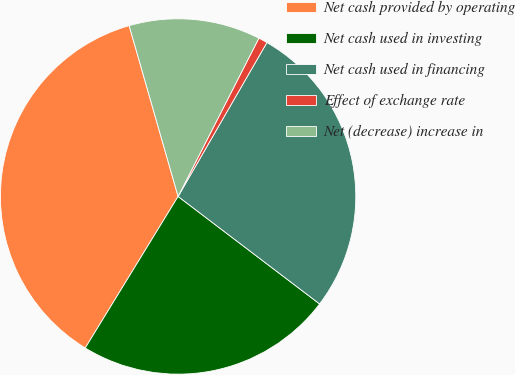Convert chart to OTSL. <chart><loc_0><loc_0><loc_500><loc_500><pie_chart><fcel>Net cash provided by operating<fcel>Net cash used in investing<fcel>Net cash used in financing<fcel>Effect of exchange rate<fcel>Net (decrease) increase in<nl><fcel>36.81%<fcel>23.41%<fcel>27.01%<fcel>0.82%<fcel>11.95%<nl></chart> 